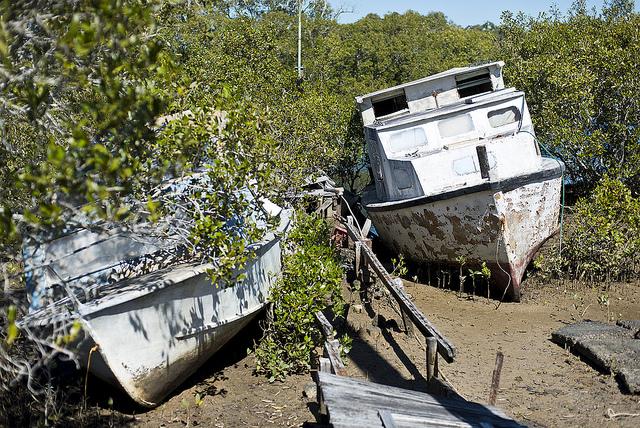Are these boats seaworthy?
Keep it brief. No. Is it sunny?
Quick response, please. Yes. Which boat is covered with more foliage?
Give a very brief answer. Left. How many boats do you see?
Concise answer only. 2. 